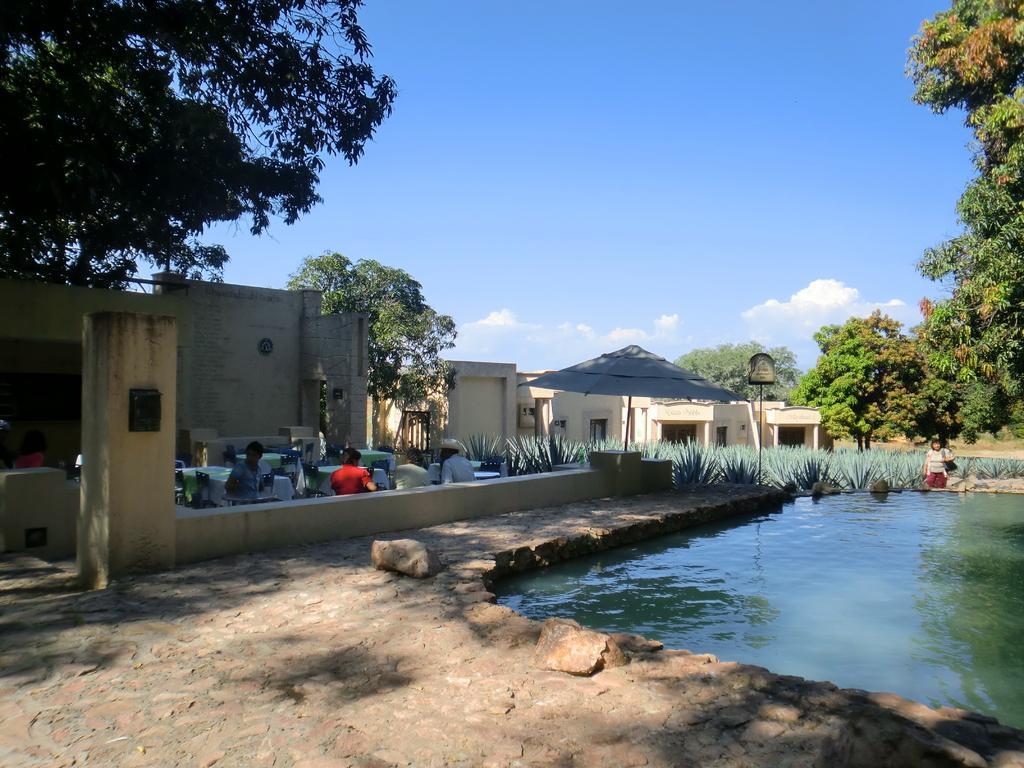How would you summarize this image in a sentence or two? In this image, we can see few houses, wall, umbrella, plants, trees. Here we can see few people. Right side of the image, we can see a person near the water. Top of the image, there is a sky. 